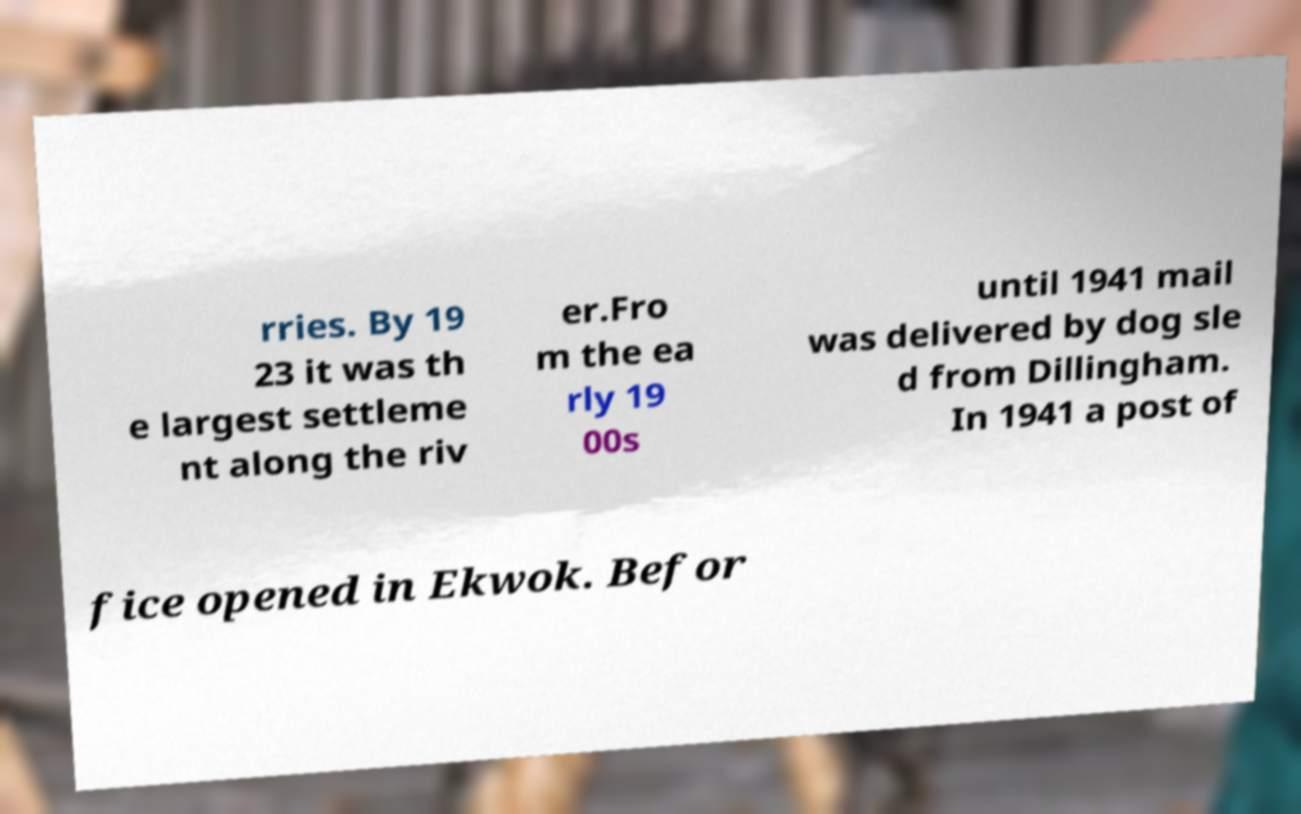For documentation purposes, I need the text within this image transcribed. Could you provide that? rries. By 19 23 it was th e largest settleme nt along the riv er.Fro m the ea rly 19 00s until 1941 mail was delivered by dog sle d from Dillingham. In 1941 a post of fice opened in Ekwok. Befor 